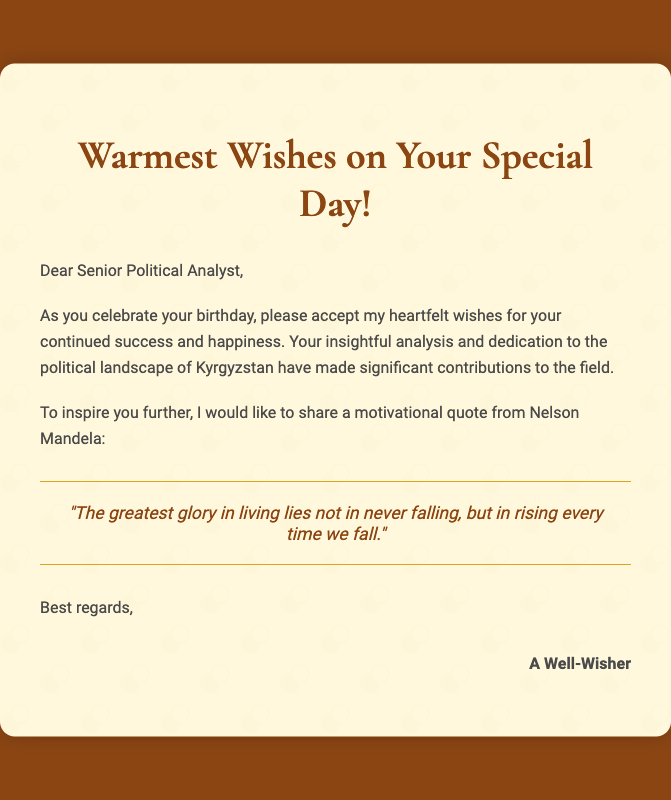What is the greeting in the card? The greeting in the card is a warm birthday wish specifically addressed to the recipient.
Answer: Warmest Wishes on Your Special Day! Who is the recipient of the card? The card is addressed to a specific individual, as directly mentioned in the salutation.
Answer: Senior Political Analyst What is the motivational quote in the card? The quote is presented in a dedicated section within the card, making it a focal point of inspiration.
Answer: "The greatest glory in living lies not in never falling, but in rising every time we fall." Who provided the birthday wishes? The closing signature indicates who has sent the greetings in the card.
Answer: A Well-Wisher What color is the background of the card? The background color is specified in the style section of the document.
Answer: #8B4513 What type of document is this? The structure and content indicate the purpose of this document.
Answer: Greeting card 